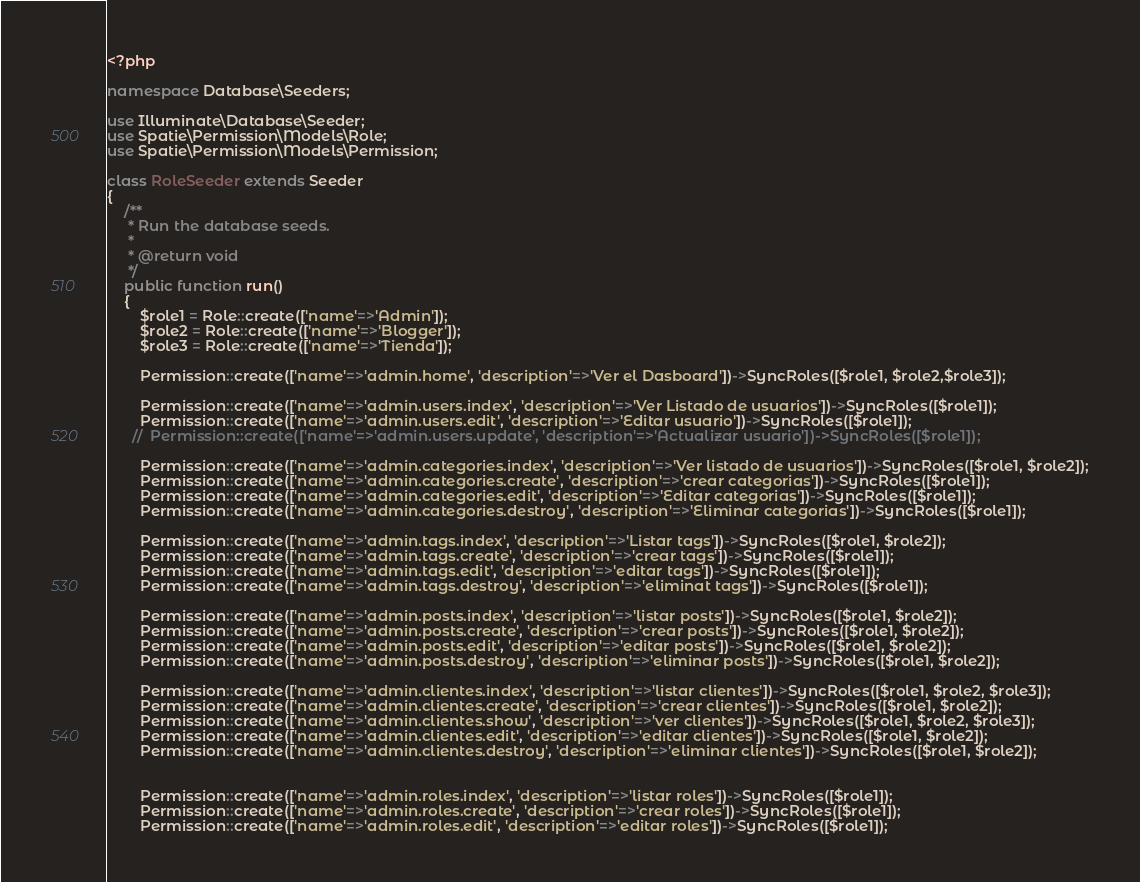Convert code to text. <code><loc_0><loc_0><loc_500><loc_500><_PHP_><?php

namespace Database\Seeders;

use Illuminate\Database\Seeder;
use Spatie\Permission\Models\Role;
use Spatie\Permission\Models\Permission;

class RoleSeeder extends Seeder
{
    /**
     * Run the database seeds.
     *
     * @return void
     */
    public function run()
    {
        $role1 = Role::create(['name'=>'Admin']);
        $role2 = Role::create(['name'=>'Blogger']);
        $role3 = Role::create(['name'=>'Tienda']);

        Permission::create(['name'=>'admin.home', 'description'=>'Ver el Dasboard'])->SyncRoles([$role1, $role2,$role3]);

        Permission::create(['name'=>'admin.users.index', 'description'=>'Ver Listado de usuarios'])->SyncRoles([$role1]);
        Permission::create(['name'=>'admin.users.edit', 'description'=>'Editar usuario'])->SyncRoles([$role1]);
      //  Permission::create(['name'=>'admin.users.update', 'description'=>'Actualizar usuario'])->SyncRoles([$role1]);

        Permission::create(['name'=>'admin.categories.index', 'description'=>'Ver listado de usuarios'])->SyncRoles([$role1, $role2]);
        Permission::create(['name'=>'admin.categories.create', 'description'=>'crear categorias'])->SyncRoles([$role1]);
        Permission::create(['name'=>'admin.categories.edit', 'description'=>'Editar categorias'])->SyncRoles([$role1]);
        Permission::create(['name'=>'admin.categories.destroy', 'description'=>'Eliminar categorias'])->SyncRoles([$role1]);

        Permission::create(['name'=>'admin.tags.index', 'description'=>'Listar tags'])->SyncRoles([$role1, $role2]);
        Permission::create(['name'=>'admin.tags.create', 'description'=>'crear tags'])->SyncRoles([$role1]);
        Permission::create(['name'=>'admin.tags.edit', 'description'=>'editar tags'])->SyncRoles([$role1]);
        Permission::create(['name'=>'admin.tags.destroy', 'description'=>'eliminat tags'])->SyncRoles([$role1]);

        Permission::create(['name'=>'admin.posts.index', 'description'=>'listar posts'])->SyncRoles([$role1, $role2]);
        Permission::create(['name'=>'admin.posts.create', 'description'=>'crear posts'])->SyncRoles([$role1, $role2]);
        Permission::create(['name'=>'admin.posts.edit', 'description'=>'editar posts'])->SyncRoles([$role1, $role2]);
        Permission::create(['name'=>'admin.posts.destroy', 'description'=>'eliminar posts'])->SyncRoles([$role1, $role2]);

        Permission::create(['name'=>'admin.clientes.index', 'description'=>'listar clientes'])->SyncRoles([$role1, $role2, $role3]);
        Permission::create(['name'=>'admin.clientes.create', 'description'=>'crear clientes'])->SyncRoles([$role1, $role2]);
        Permission::create(['name'=>'admin.clientes.show', 'description'=>'ver clientes'])->SyncRoles([$role1, $role2, $role3]);
        Permission::create(['name'=>'admin.clientes.edit', 'description'=>'editar clientes'])->SyncRoles([$role1, $role2]);
        Permission::create(['name'=>'admin.clientes.destroy', 'description'=>'eliminar clientes'])->SyncRoles([$role1, $role2]);


        Permission::create(['name'=>'admin.roles.index', 'description'=>'listar roles'])->SyncRoles([$role1]);
        Permission::create(['name'=>'admin.roles.create', 'description'=>'crear roles'])->SyncRoles([$role1]);
        Permission::create(['name'=>'admin.roles.edit', 'description'=>'editar roles'])->SyncRoles([$role1]);</code> 